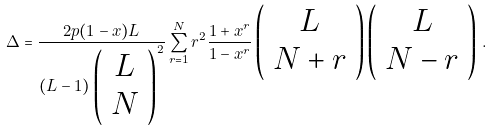Convert formula to latex. <formula><loc_0><loc_0><loc_500><loc_500>\Delta = \frac { 2 p ( 1 - x ) L } { ( L - 1 ) \left ( \begin{array} { c } L \\ N \end{array} \right ) ^ { 2 } } \sum _ { r = 1 } ^ { N } r ^ { 2 } \frac { 1 + x ^ { r } } { 1 - x ^ { r } } \left ( \begin{array} { c } L \\ N + r \end{array} \right ) \left ( \begin{array} { c } L \\ N - r \end{array} \right ) \, .</formula> 